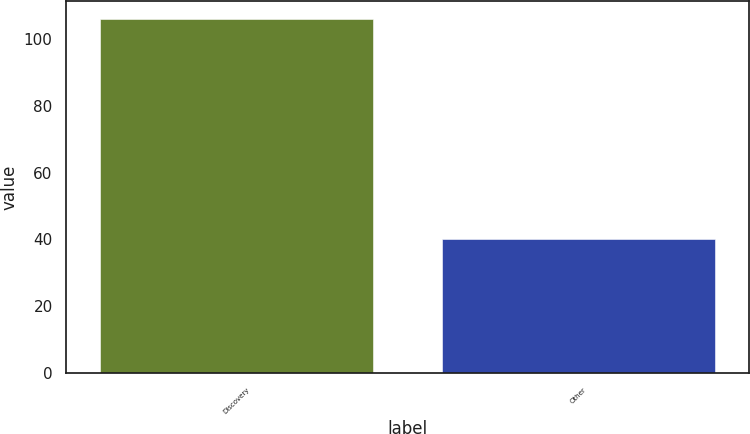<chart> <loc_0><loc_0><loc_500><loc_500><bar_chart><fcel>Discovery<fcel>Other<nl><fcel>106<fcel>40<nl></chart> 